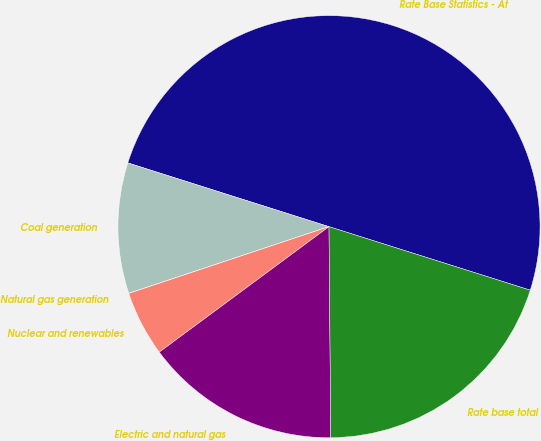Convert chart to OTSL. <chart><loc_0><loc_0><loc_500><loc_500><pie_chart><fcel>Rate Base Statistics - At<fcel>Coal generation<fcel>Natural gas generation<fcel>Nuclear and renewables<fcel>Electric and natural gas<fcel>Rate base total<nl><fcel>49.98%<fcel>10.0%<fcel>0.01%<fcel>5.01%<fcel>15.0%<fcel>20.0%<nl></chart> 